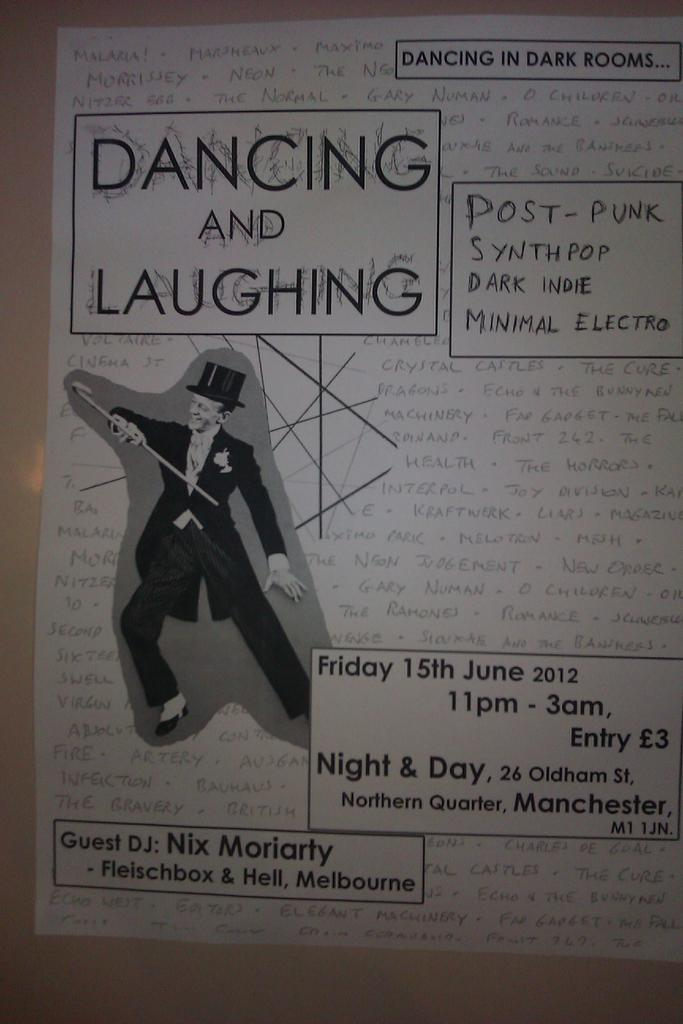Provide a one-sentence caption for the provided image. A club flyer promises different types of music and a guest DJ. 